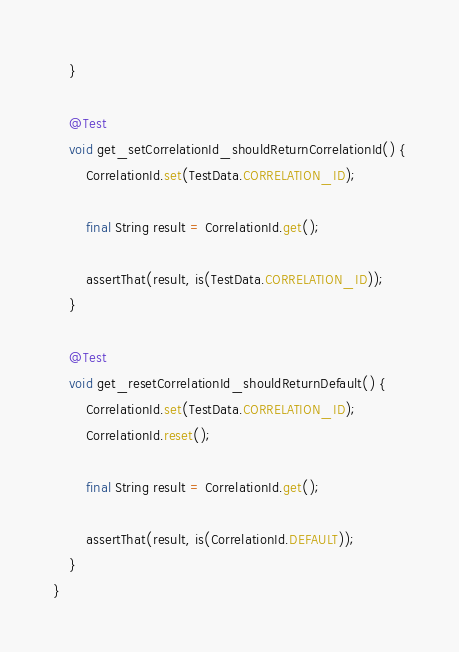<code> <loc_0><loc_0><loc_500><loc_500><_Java_>    }

    @Test
    void get_setCorrelationId_shouldReturnCorrelationId() {
        CorrelationId.set(TestData.CORRELATION_ID);

        final String result = CorrelationId.get();

        assertThat(result, is(TestData.CORRELATION_ID));
    }

    @Test
    void get_resetCorrelationId_shouldReturnDefault() {
        CorrelationId.set(TestData.CORRELATION_ID);
        CorrelationId.reset();

        final String result = CorrelationId.get();

        assertThat(result, is(CorrelationId.DEFAULT));
    }
}</code> 